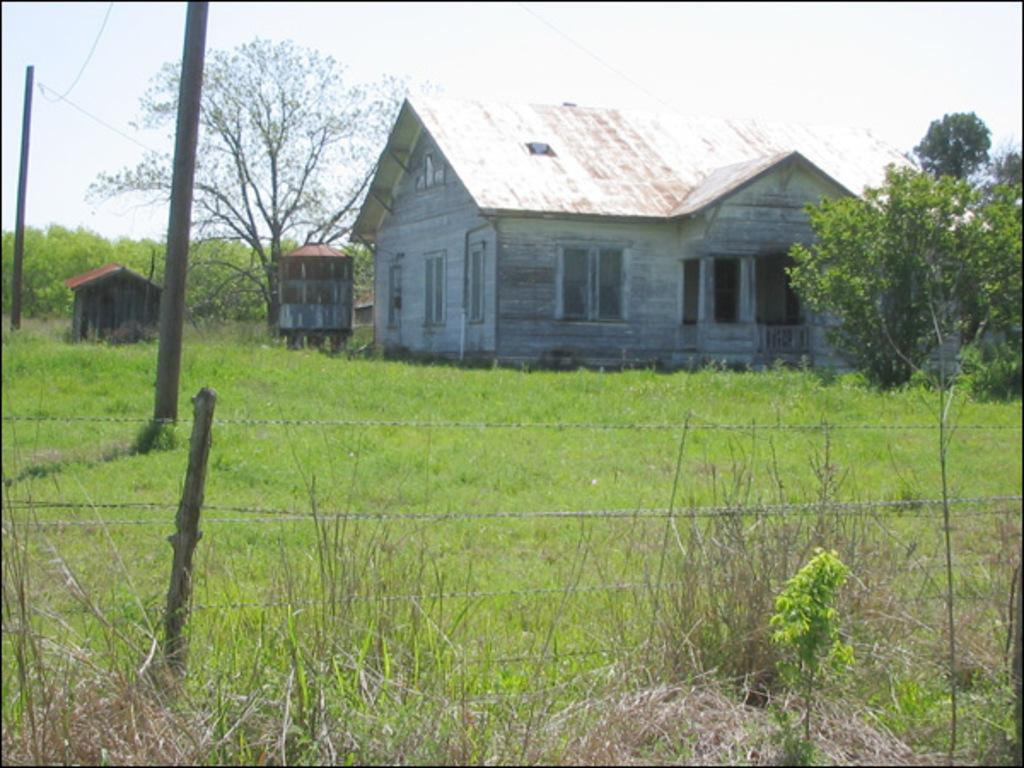What material is the house made of in the image? The house is made of wood. Is there any other structure near the house? Yes, there is a small hut beside the house. What type of vegetation is present around the house? There is a lot of grass around the house. Are there any other natural elements visible in the image? Yes, there are trees around the house. What type of pickle is being served at the governor's event near the coast in the image? There is no governor, pickle, or coast present in the image. 